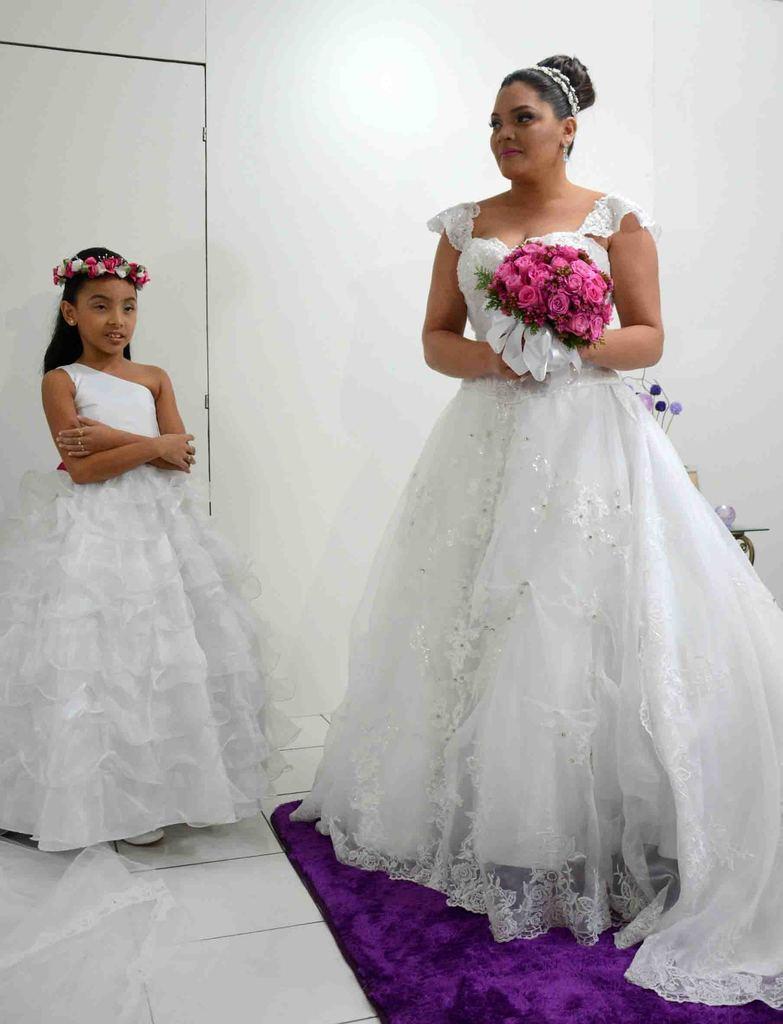Describe this image in one or two sentences. In this image I can see a girl and woman wore a white dress. Woman is holding a bouquet and girl wore a crown. In the background of the image there is a white wall and objects. On the tile floor there is a white cloth and purple cloth.  